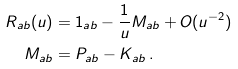Convert formula to latex. <formula><loc_0><loc_0><loc_500><loc_500>R _ { a b } ( u ) & = 1 _ { a b } - \frac { 1 } { u } M _ { a b } + O ( u ^ { - 2 } ) \\ M _ { a b } & = P _ { a b } - K _ { a b } \, .</formula> 